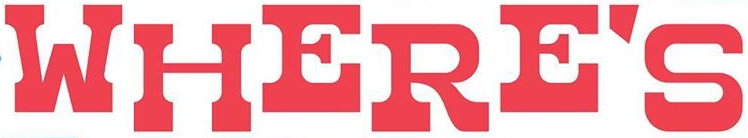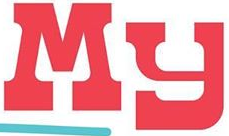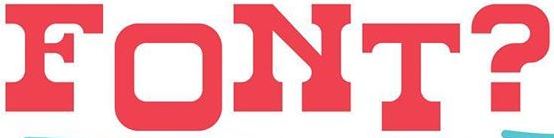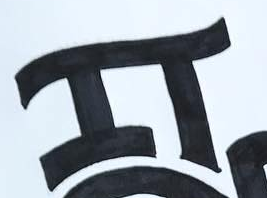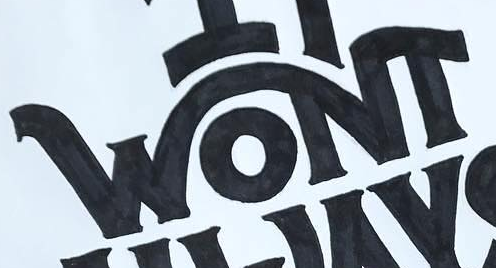What text is displayed in these images sequentially, separated by a semicolon? WHERE'S; My; FONT?; IT; WONT 